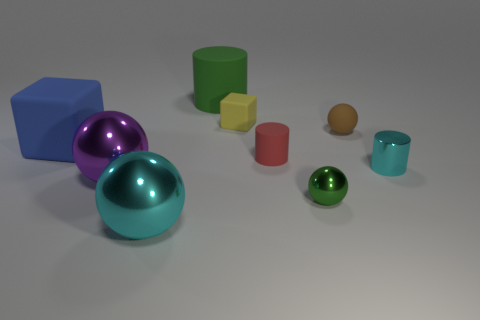The green object that is the same material as the blue thing is what size?
Your response must be concise. Large. There is a brown rubber ball that is on the left side of the tiny metal cylinder; what is its size?
Give a very brief answer. Small. What number of metallic cylinders have the same size as the green metal object?
Your answer should be compact. 1. The object that is the same color as the small metal ball is what size?
Your answer should be compact. Large. Is there a object of the same color as the shiny cylinder?
Your answer should be very brief. Yes. There is a matte block that is the same size as the green rubber cylinder; what color is it?
Provide a succinct answer. Blue. Do the small metal cylinder and the big thing that is in front of the large purple sphere have the same color?
Offer a very short reply. Yes. The big matte cube is what color?
Your answer should be very brief. Blue. What is the material of the cube that is left of the big green rubber cylinder?
Your answer should be very brief. Rubber. There is another rubber thing that is the same shape as the red matte thing; what is its size?
Your answer should be very brief. Large. 